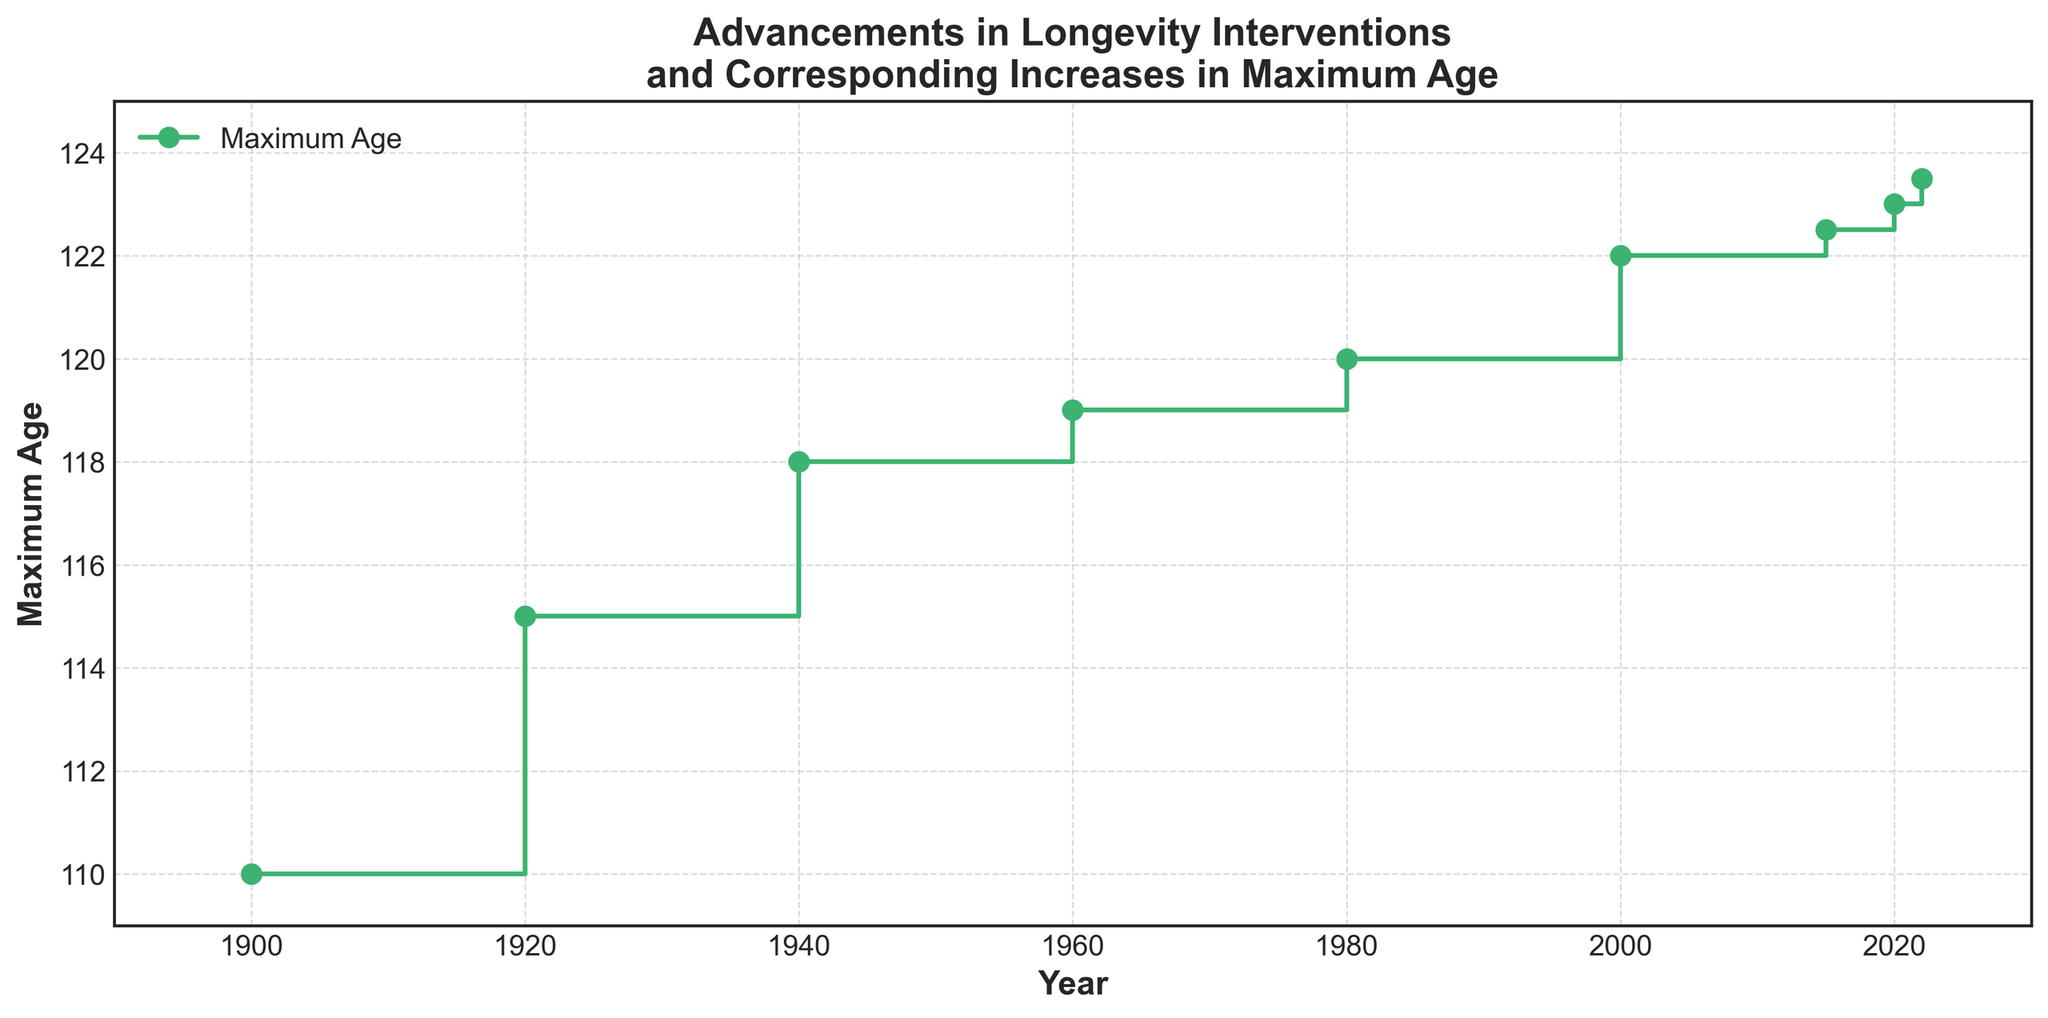What pattern do you observe in the maximum age increases during the 20th century? During the 20th century, maxima increased steadily, especially during the first part of the century, from 110 years in 1900 to 120 years by 1980. Each increase generally took around 20 years.
Answer: Steady increase How many years did it take for the maximum age to increase from 118 to 122? The maximum age was 118 in 1940 and reached 122 in 2000. Thus, the time taken for this increase is 2000 - 1940 = 60 years.
Answer: 60 years Between which years did the maximum age see the largest increase? Looking at the step plot, the largest increase in age occurred between 1900 (110 years) and 1920 (115 years), which is an increase of 5 years.
Answer: 1900 to 1920 Which year had the smallest increase in maximum age compared to the previous data point, and what was that increase? The smallest increase happened between 2015 (122.5 years) and 2020 (123 years), which is an increase of only 0.5 years.
Answer: 2020, 0.5 years What is the average maximum age from 1900 to 2022, inclusive? Calculate the average by summing all given maximum ages (110 + 115 + 118 + 119 + 120 + 122 + 122.5 + 123 + 123.5) = 973. Divide by the number of data points (9). Thus, 973/9 ≈ 108.1.
Answer: 108.1 How does the period from 2000 to 2022 compare to the period from 1920 to 1940 in terms of increases in maximum age? From 1920 to 1940, the maximum age increased from 115 to 118 (a 3-year increase). From 2000 to 2022, it increased from 122 to 123.5 (a 1.5-year increase). Hence, the earlier period witnessed a larger increase.
Answer: 1920-1940 had a larger increase Was there any period when the maximum age didn’t change? If so, when? Yes, from 2000 to 2015, the maximum age remained at 122 years.
Answer: 2000 to 2015 What is the approximate rate of increase in maximum age per decade from 1900 to 1980? From 1900 (110 years) to 1980 (120 years), the increase is 10 years over 8 decades, making the rate 10/8 = 1.25 years per decade.
Answer: 1.25 years/decade From 1980 onwards, what was the largest increase observed over a five-year period? The largest observed increase over a specified five-year period after 1980 was between 2020 (123 years) and 2022 (123.5 years), showing an increase of 0.5 years.
Answer: 0.5 years 